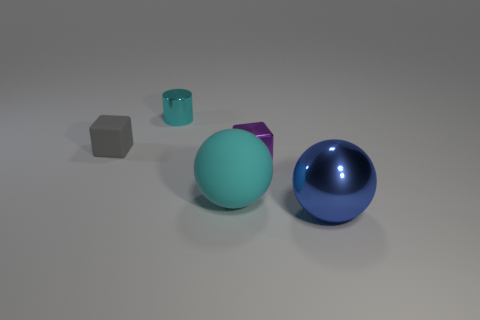Add 3 blue metal objects. How many objects exist? 8 Subtract 1 blue spheres. How many objects are left? 4 Subtract all spheres. How many objects are left? 3 Subtract all gray rubber cylinders. Subtract all large cyan matte balls. How many objects are left? 4 Add 4 cyan cylinders. How many cyan cylinders are left? 5 Add 3 cyan cylinders. How many cyan cylinders exist? 4 